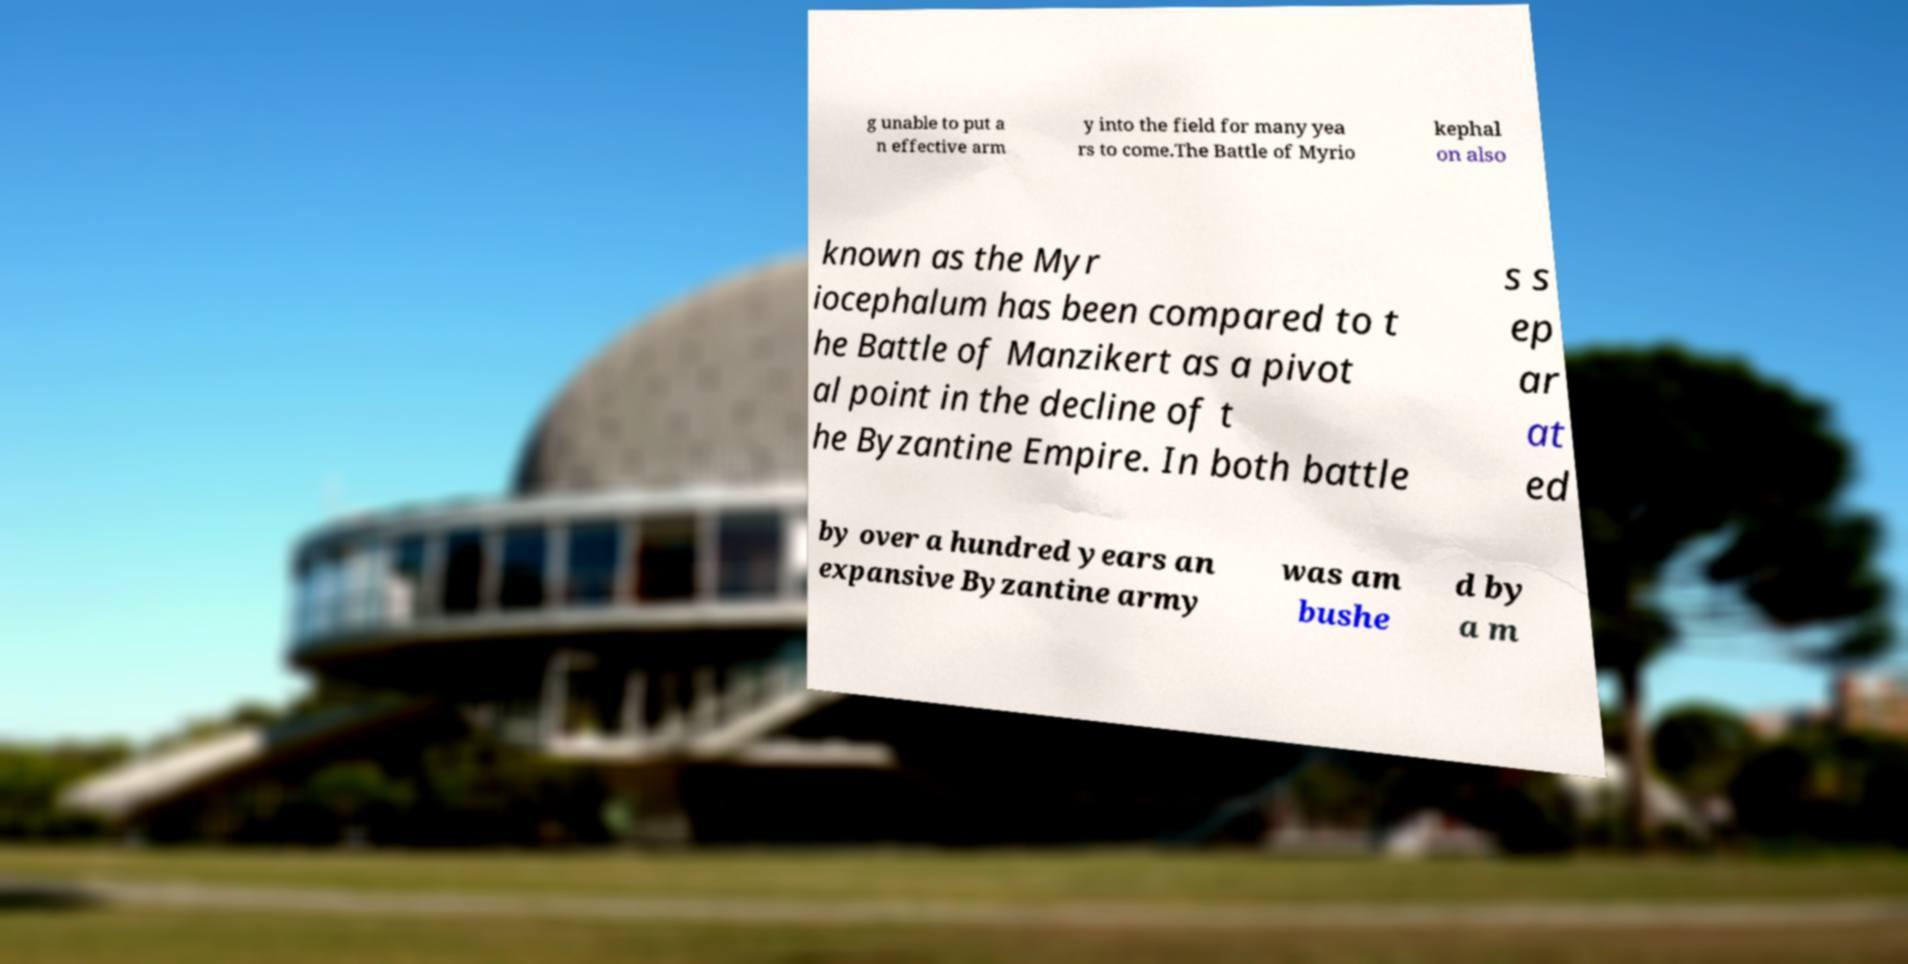What messages or text are displayed in this image? I need them in a readable, typed format. g unable to put a n effective arm y into the field for many yea rs to come.The Battle of Myrio kephal on also known as the Myr iocephalum has been compared to t he Battle of Manzikert as a pivot al point in the decline of t he Byzantine Empire. In both battle s s ep ar at ed by over a hundred years an expansive Byzantine army was am bushe d by a m 